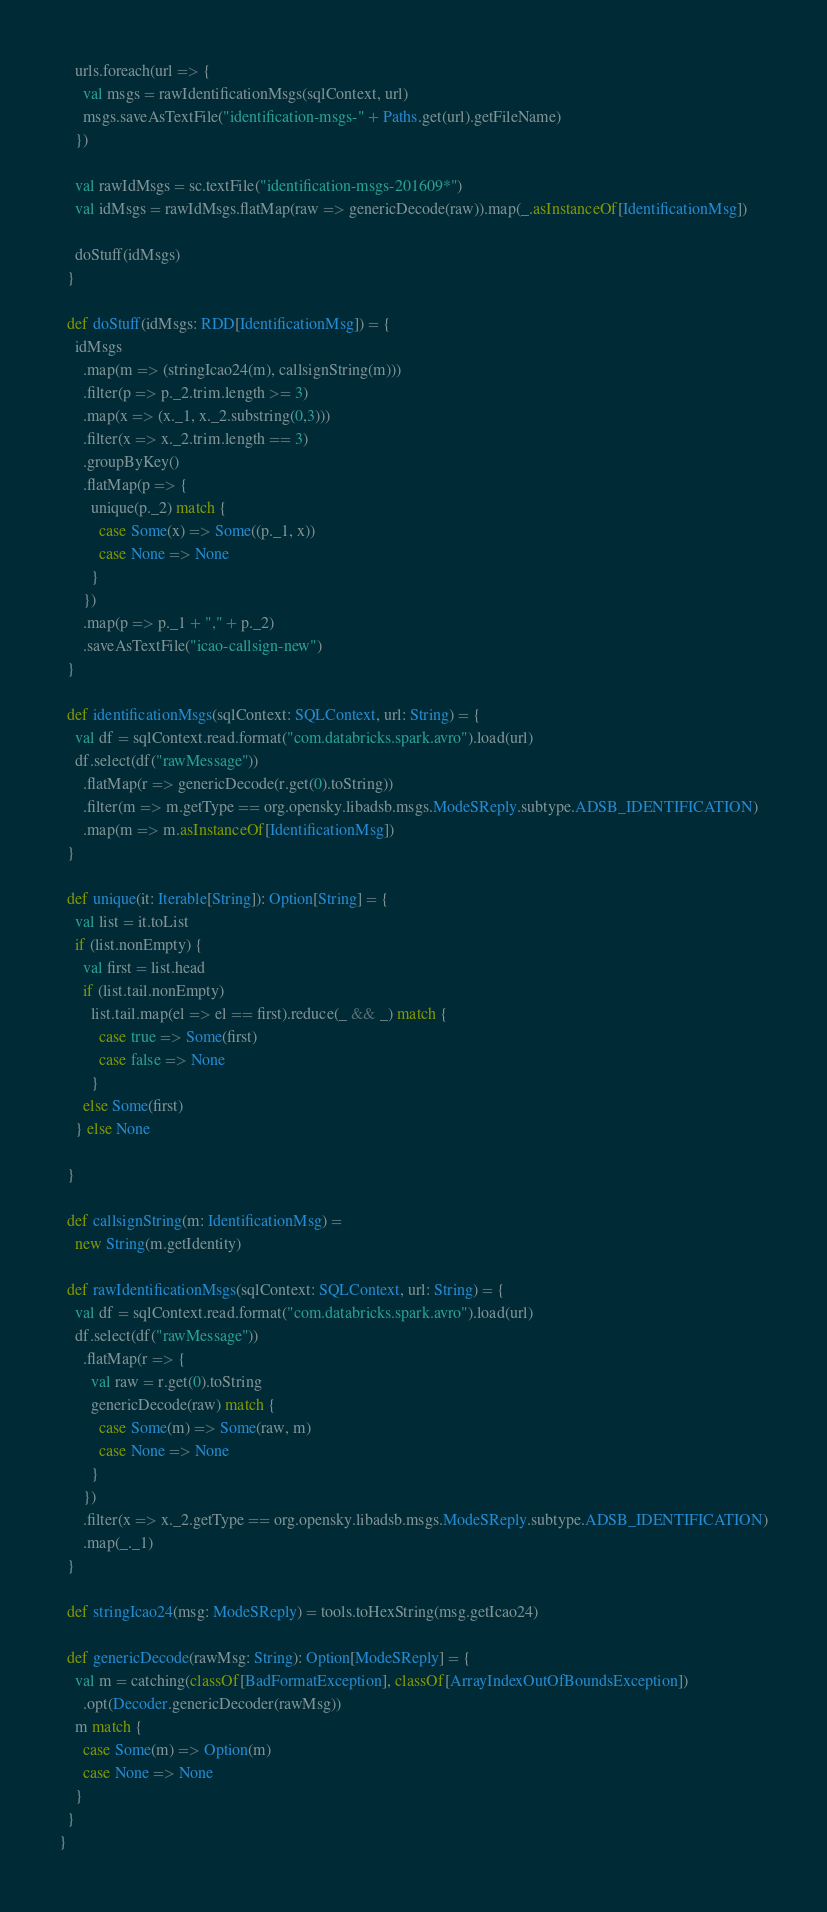Convert code to text. <code><loc_0><loc_0><loc_500><loc_500><_Scala_>
    urls.foreach(url => {
      val msgs = rawIdentificationMsgs(sqlContext, url)
      msgs.saveAsTextFile("identification-msgs-" + Paths.get(url).getFileName)
    })

    val rawIdMsgs = sc.textFile("identification-msgs-201609*")
    val idMsgs = rawIdMsgs.flatMap(raw => genericDecode(raw)).map(_.asInstanceOf[IdentificationMsg])

    doStuff(idMsgs)
  }

  def doStuff(idMsgs: RDD[IdentificationMsg]) = {
    idMsgs
      .map(m => (stringIcao24(m), callsignString(m)))
      .filter(p => p._2.trim.length >= 3)
      .map(x => (x._1, x._2.substring(0,3)))
      .filter(x => x._2.trim.length == 3)
      .groupByKey()
      .flatMap(p => {
        unique(p._2) match {
          case Some(x) => Some((p._1, x))
          case None => None
        }
      })
      .map(p => p._1 + "," + p._2)
      .saveAsTextFile("icao-callsign-new")
  }

  def identificationMsgs(sqlContext: SQLContext, url: String) = {
    val df = sqlContext.read.format("com.databricks.spark.avro").load(url)
    df.select(df("rawMessage"))
      .flatMap(r => genericDecode(r.get(0).toString))
      .filter(m => m.getType == org.opensky.libadsb.msgs.ModeSReply.subtype.ADSB_IDENTIFICATION)
      .map(m => m.asInstanceOf[IdentificationMsg])
  }

  def unique(it: Iterable[String]): Option[String] = {
    val list = it.toList
    if (list.nonEmpty) {
      val first = list.head
      if (list.tail.nonEmpty)
        list.tail.map(el => el == first).reduce(_ && _) match {
          case true => Some(first)
          case false => None
        }
      else Some(first)
    } else None

  }

  def callsignString(m: IdentificationMsg) =
    new String(m.getIdentity)

  def rawIdentificationMsgs(sqlContext: SQLContext, url: String) = {
    val df = sqlContext.read.format("com.databricks.spark.avro").load(url)
    df.select(df("rawMessage"))
      .flatMap(r => {
        val raw = r.get(0).toString
        genericDecode(raw) match {
          case Some(m) => Some(raw, m)
          case None => None
        }
      })
      .filter(x => x._2.getType == org.opensky.libadsb.msgs.ModeSReply.subtype.ADSB_IDENTIFICATION)
      .map(_._1)
  }

  def stringIcao24(msg: ModeSReply) = tools.toHexString(msg.getIcao24)

  def genericDecode(rawMsg: String): Option[ModeSReply] = {
    val m = catching(classOf[BadFormatException], classOf[ArrayIndexOutOfBoundsException])
      .opt(Decoder.genericDecoder(rawMsg))
    m match {
      case Some(m) => Option(m)
      case None => None
    }
  }
}
</code> 